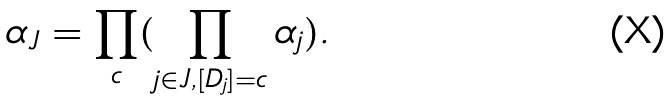<formula> <loc_0><loc_0><loc_500><loc_500>\alpha _ { J } = \prod _ { c } ( \prod _ { j \in J , [ D _ { j } ] = c } \alpha _ { j } ) .</formula> 